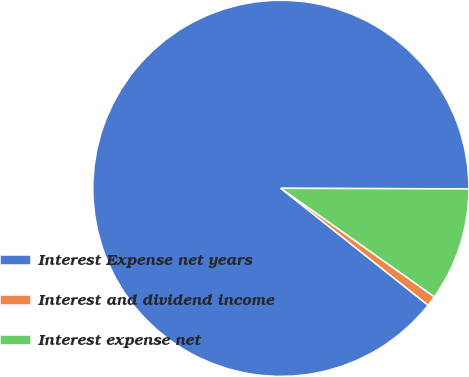Convert chart. <chart><loc_0><loc_0><loc_500><loc_500><pie_chart><fcel>Interest Expense net years<fcel>Interest and dividend income<fcel>Interest expense net<nl><fcel>89.37%<fcel>0.89%<fcel>9.74%<nl></chart> 